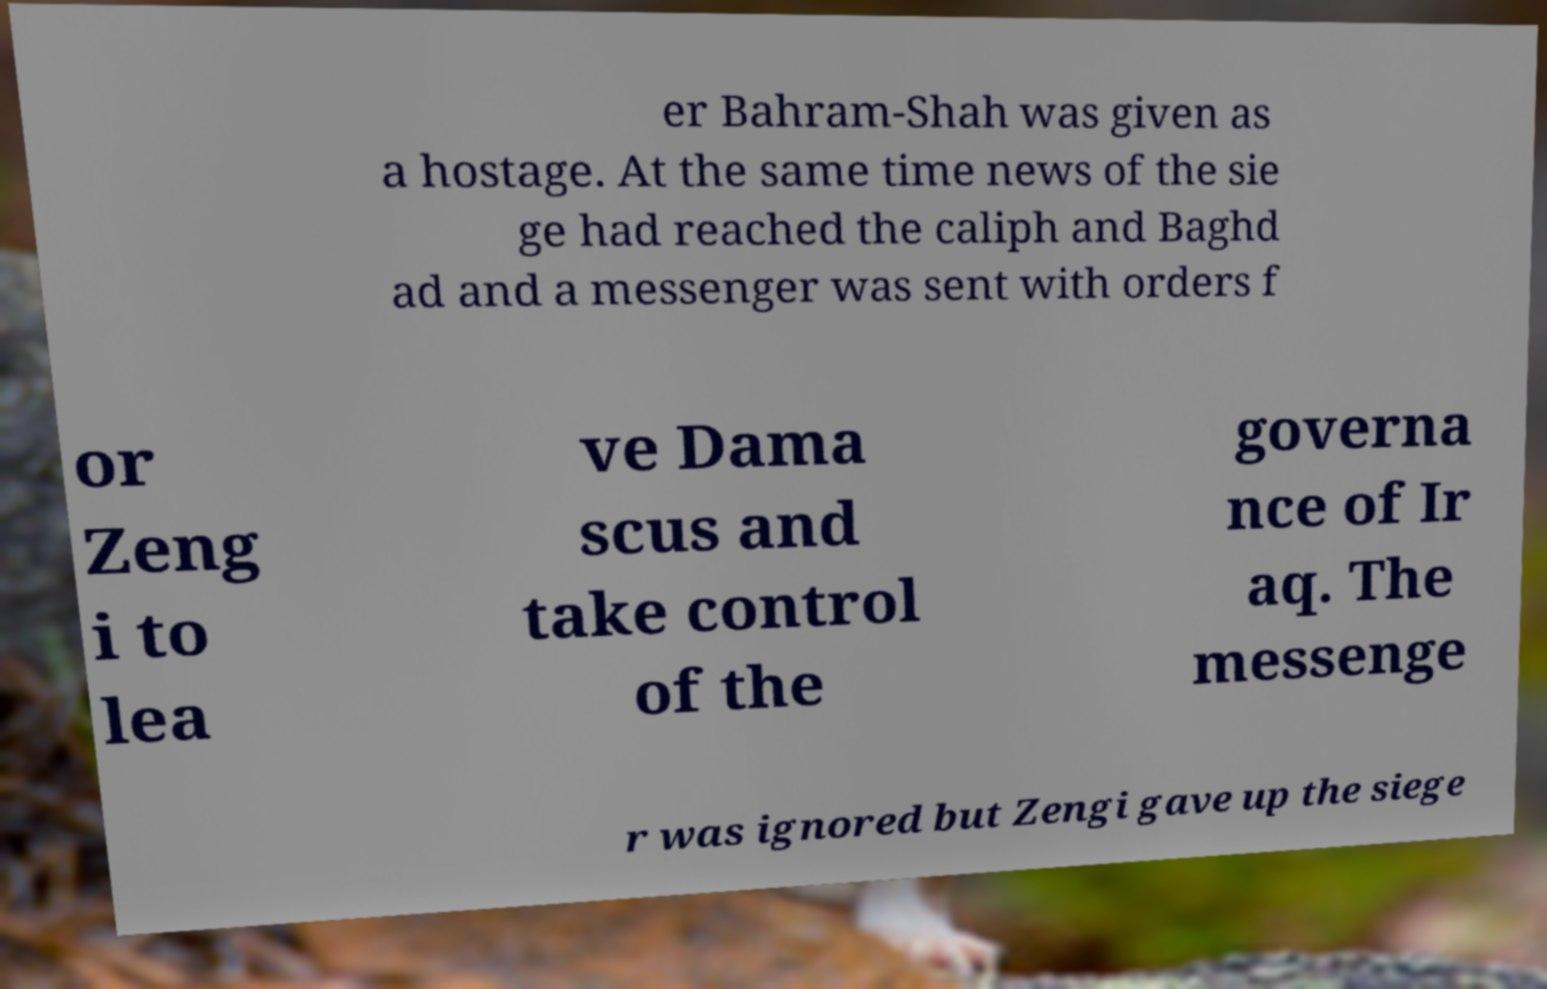Could you extract and type out the text from this image? er Bahram-Shah was given as a hostage. At the same time news of the sie ge had reached the caliph and Baghd ad and a messenger was sent with orders f or Zeng i to lea ve Dama scus and take control of the governa nce of Ir aq. The messenge r was ignored but Zengi gave up the siege 